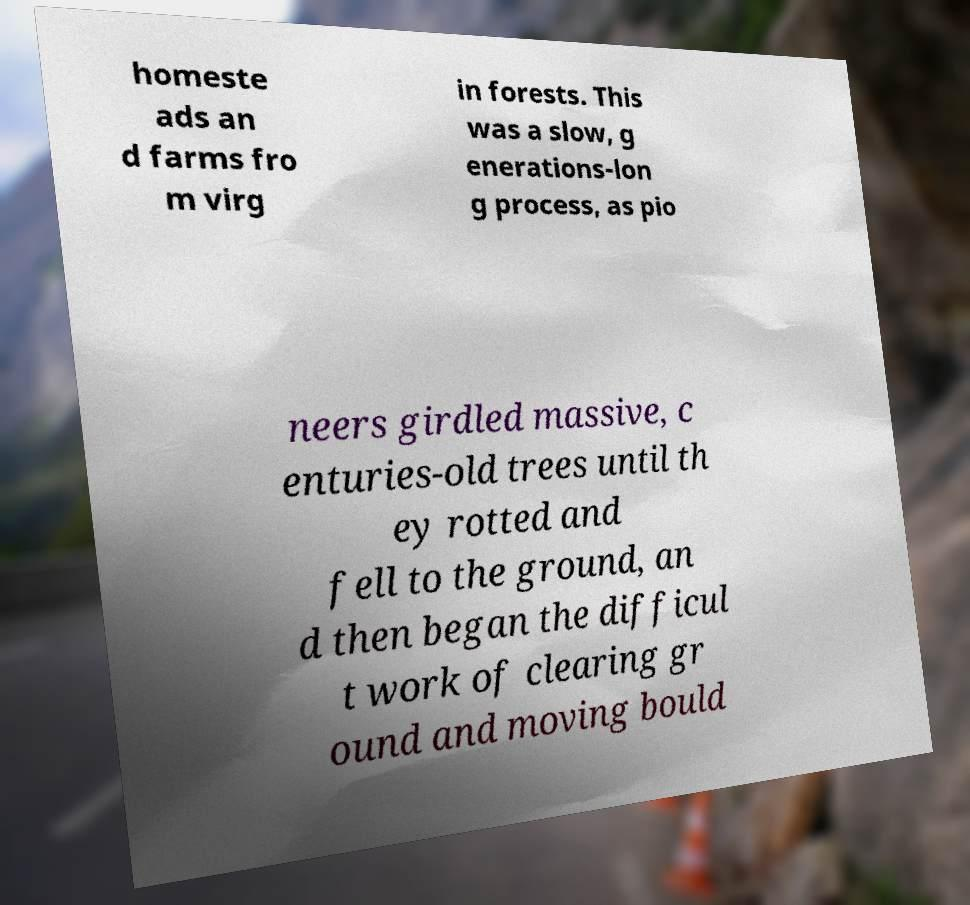Could you assist in decoding the text presented in this image and type it out clearly? homeste ads an d farms fro m virg in forests. This was a slow, g enerations-lon g process, as pio neers girdled massive, c enturies-old trees until th ey rotted and fell to the ground, an d then began the difficul t work of clearing gr ound and moving bould 